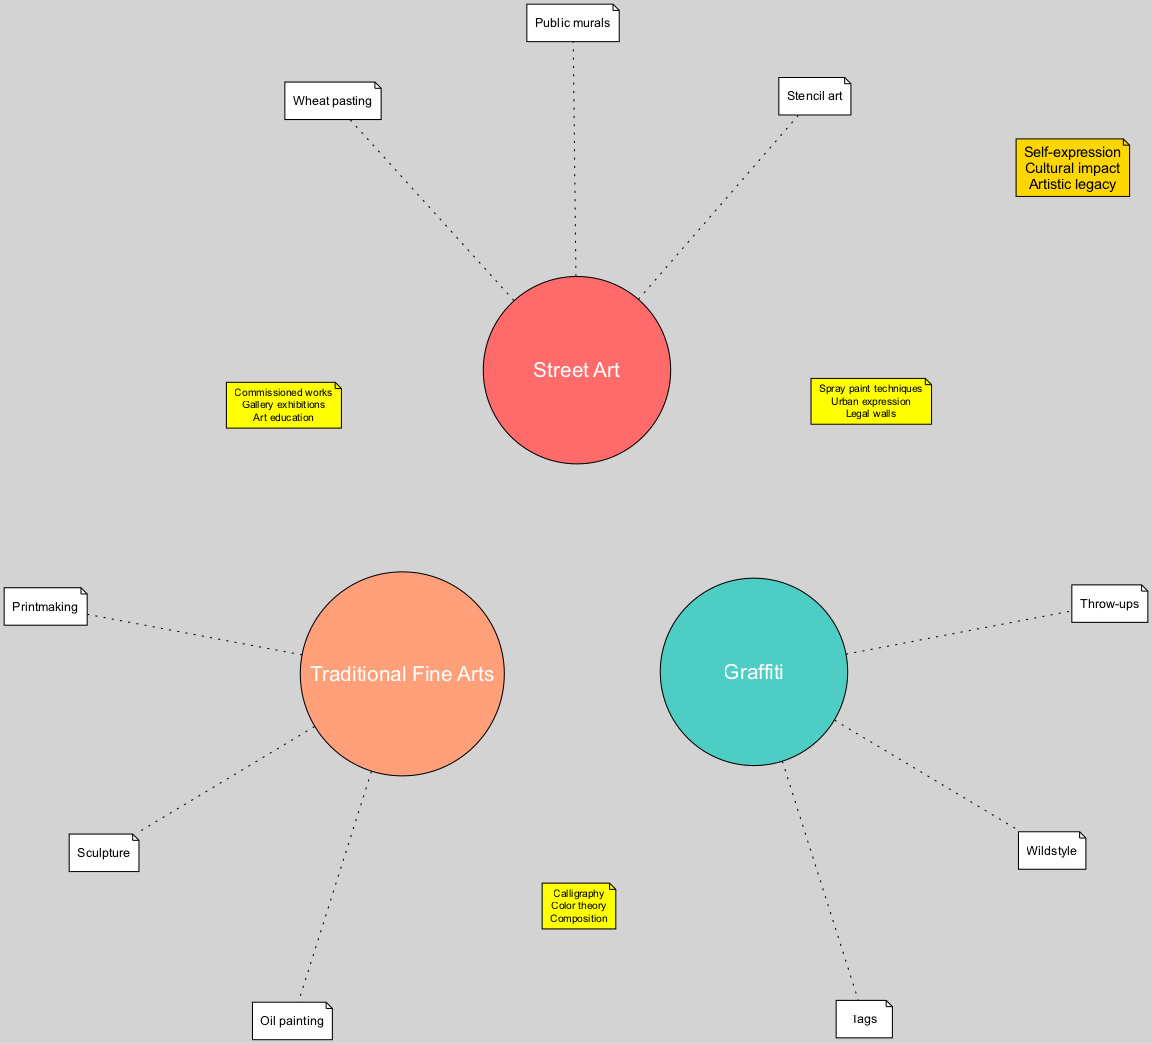What are the elements of Street Art? The diagram lists three distinct elements under the Street Art category: Public murals, Stencil art, and Wheat pasting. This information can be found by locating the Street Art node and reviewing the elements connected to it.
Answer: Public murals, Stencil art, Wheat pasting How many elements are shown in the Graffiti section? The Graffiti section contains three elements: Tags, Throw-ups, and Wildstyle. Counting these elements is straightforward by viewing the list drawn out from the Graffiti node.
Answer: 3 What intersection involves elements from Street Art and Traditional Fine Arts? The intersection between Street Art and Traditional Fine Arts contains three shared elements: Commissioned works, Gallery exhibitions, and Art education. To identify this intersection, one must locate the interplay between these two categories.
Answer: Commissioned works, Gallery exhibitions, Art education Which element links Graffiti and Traditional Fine Arts? The shared elements between Graffiti and Traditional Fine Arts are Calligraphy, Color theory, and Composition. This relationship can be observed by examining the connecting elements between the Graffiti and Traditional Fine Arts nodes.
Answer: Calligraphy, Color theory, Composition What does the center represent? The center of the Venn diagram symbolizes the shared themes across all three categories, which are Self-expression, Cultural impact, and Artistic legacy. This is determined by recognizing that the center node encompasses elements that overlap between Street Art, Graffiti, and Traditional Fine Arts.
Answer: Self-expression, Cultural impact, Artistic legacy How many unique elements are in the Street Art category? In the Street Art category, there are three unique elements listed: Public murals, Stencil art, and Wheat pasting. By referring directly to the elements under the Street Art node, one confirms this quantity.
Answer: 3 What color represents Traditional Fine Arts? The Traditional Fine Arts section is represented by the color #FFA07A. This information can be found by examining the specific color assigned to the Traditional Fine Arts node in the diagram.
Answer: #FFA07A How many total unique elements are listed across all categories? The total unique elements across all three categories can be calculated as follows: 3 from Street Art, 3 from Graffiti, and 3 from Traditional Fine Arts, which totals 9 unique elements.
Answer: 9 What connection does Urban expression have? Urban expression is a shared element between Street Art and Graffiti. This connection can be easily identified within the intersection designated for these two art forms.
Answer: Urban expression What theme is emphasized by the center of the diagram? The center emphasizes themes of Self-expression, Cultural impact, and Artistic legacy, illustrating the common ground shared by all three art forms. This is seen by examining the overlapping section of the Venn diagram.
Answer: Self-expression, Cultural impact, Artistic legacy 